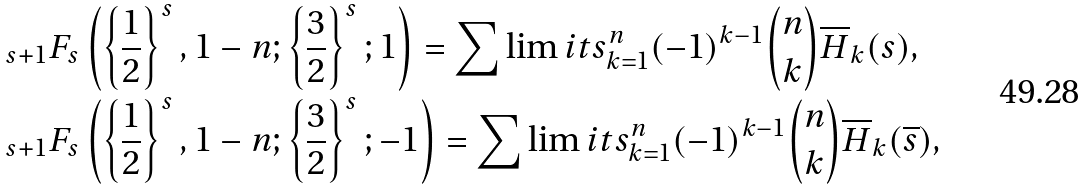<formula> <loc_0><loc_0><loc_500><loc_500>& { _ { s + 1 } } F _ { s } \left ( \left \{ \frac { 1 } { 2 } \right \} ^ { s } , 1 - n ; \left \{ \frac { 3 } { 2 } \right \} ^ { s } ; 1 \right ) = \sum \lim i t s _ { k = 1 } ^ { n } ( - 1 ) ^ { k - 1 } \binom { n } { k } \overline { H } _ { k } ( s ) , \\ & { _ { s + 1 } } F _ { s } \left ( \left \{ \frac { 1 } { 2 } \right \} ^ { s } , 1 - n ; \left \{ \frac { 3 } { 2 } \right \} ^ { s } ; - 1 \right ) = \sum \lim i t s _ { k = 1 } ^ { n } ( - 1 ) ^ { k - 1 } \binom { n } { k } \overline { H } _ { k } ( \overline { s } ) ,</formula> 